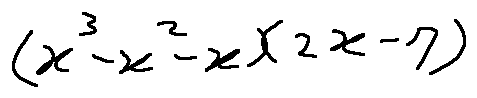Convert formula to latex. <formula><loc_0><loc_0><loc_500><loc_500>( x ^ { 3 } - x ^ { 2 } - x ) ( 2 x - 7 )</formula> 